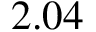<formula> <loc_0><loc_0><loc_500><loc_500>2 . 0 4</formula> 